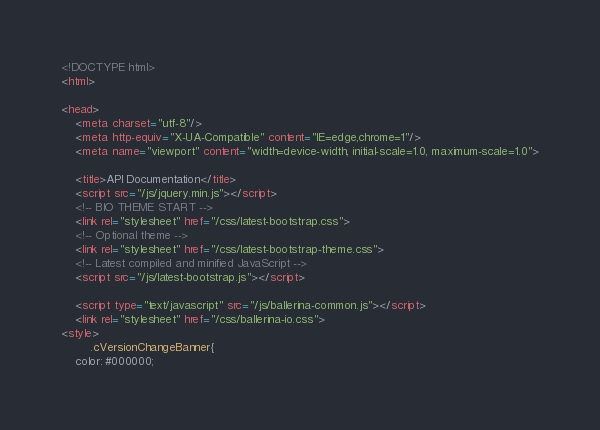Convert code to text. <code><loc_0><loc_0><loc_500><loc_500><_HTML_><!DOCTYPE html>
<html>

<head>
    <meta charset="utf-8"/>
    <meta http-equiv="X-UA-Compatible" content="IE=edge,chrome=1"/>
    <meta name="viewport" content="width=device-width, initial-scale=1.0, maximum-scale=1.0">

    <title>API Documentation</title>
    <script src="/js/jquery.min.js"></script>
    <!-- BIO THEME START -->
    <link rel="stylesheet" href="/css/latest-bootstrap.css">
    <!-- Optional theme -->
    <link rel="stylesheet" href="/css/latest-bootstrap-theme.css">
    <!-- Latest compiled and minified JavaScript -->
    <script src="/js/latest-bootstrap.js"></script>

    <script type="text/javascript" src="/js/ballerina-common.js"></script>
    <link rel="stylesheet" href="/css/ballerina-io.css">
<style>
        .cVersionChangeBanner{
    color: #000000;</code> 